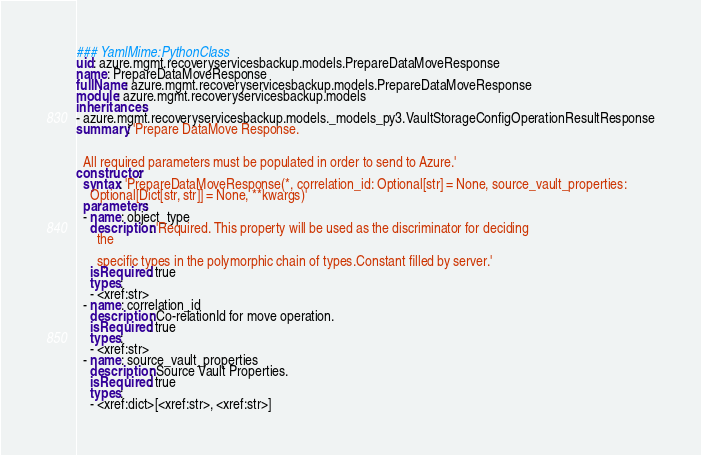<code> <loc_0><loc_0><loc_500><loc_500><_YAML_>### YamlMime:PythonClass
uid: azure.mgmt.recoveryservicesbackup.models.PrepareDataMoveResponse
name: PrepareDataMoveResponse
fullName: azure.mgmt.recoveryservicesbackup.models.PrepareDataMoveResponse
module: azure.mgmt.recoveryservicesbackup.models
inheritances:
- azure.mgmt.recoveryservicesbackup.models._models_py3.VaultStorageConfigOperationResultResponse
summary: 'Prepare DataMove Response.


  All required parameters must be populated in order to send to Azure.'
constructor:
  syntax: 'PrepareDataMoveResponse(*, correlation_id: Optional[str] = None, source_vault_properties:
    Optional[Dict[str, str]] = None, **kwargs)'
  parameters:
  - name: object_type
    description: 'Required. This property will be used as the discriminator for deciding
      the

      specific types in the polymorphic chain of types.Constant filled by server.'
    isRequired: true
    types:
    - <xref:str>
  - name: correlation_id
    description: Co-relationId for move operation.
    isRequired: true
    types:
    - <xref:str>
  - name: source_vault_properties
    description: Source Vault Properties.
    isRequired: true
    types:
    - <xref:dict>[<xref:str>, <xref:str>]
</code> 